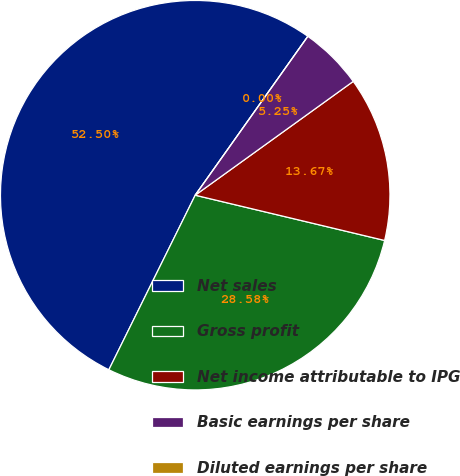Convert chart to OTSL. <chart><loc_0><loc_0><loc_500><loc_500><pie_chart><fcel>Net sales<fcel>Gross profit<fcel>Net income attributable to IPG<fcel>Basic earnings per share<fcel>Diluted earnings per share<nl><fcel>52.51%<fcel>28.58%<fcel>13.67%<fcel>5.25%<fcel>0.0%<nl></chart> 